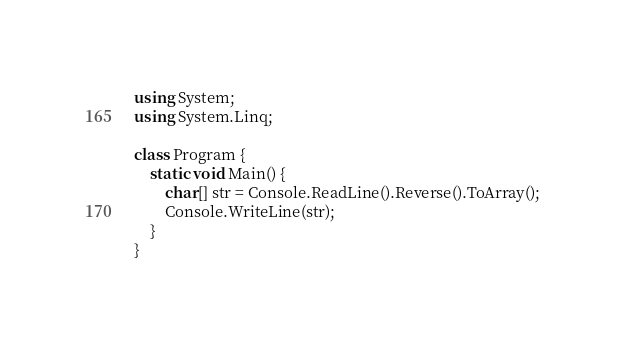Convert code to text. <code><loc_0><loc_0><loc_500><loc_500><_C#_>using System;
using System.Linq;

class Program {
    static void Main() {
        char[] str = Console.ReadLine().Reverse().ToArray();
        Console.WriteLine(str);
    }
}
</code> 